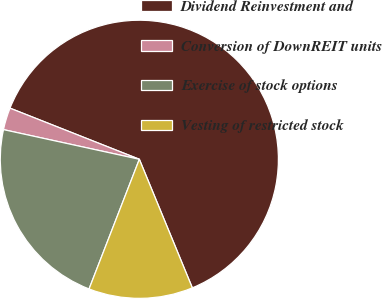Convert chart to OTSL. <chart><loc_0><loc_0><loc_500><loc_500><pie_chart><fcel>Dividend Reinvestment and<fcel>Conversion of DownREIT units<fcel>Exercise of stock options<fcel>Vesting of restricted stock<nl><fcel>62.78%<fcel>2.57%<fcel>22.53%<fcel>12.11%<nl></chart> 